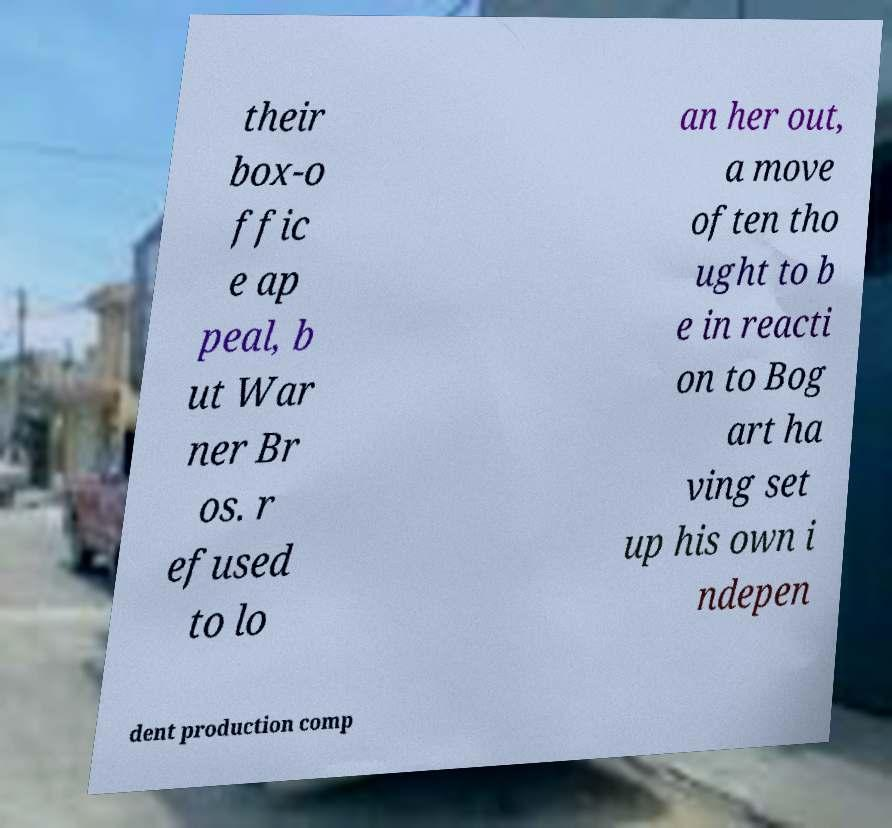Please identify and transcribe the text found in this image. their box-o ffic e ap peal, b ut War ner Br os. r efused to lo an her out, a move often tho ught to b e in reacti on to Bog art ha ving set up his own i ndepen dent production comp 